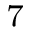Convert formula to latex. <formula><loc_0><loc_0><loc_500><loc_500>_ { 7 }</formula> 